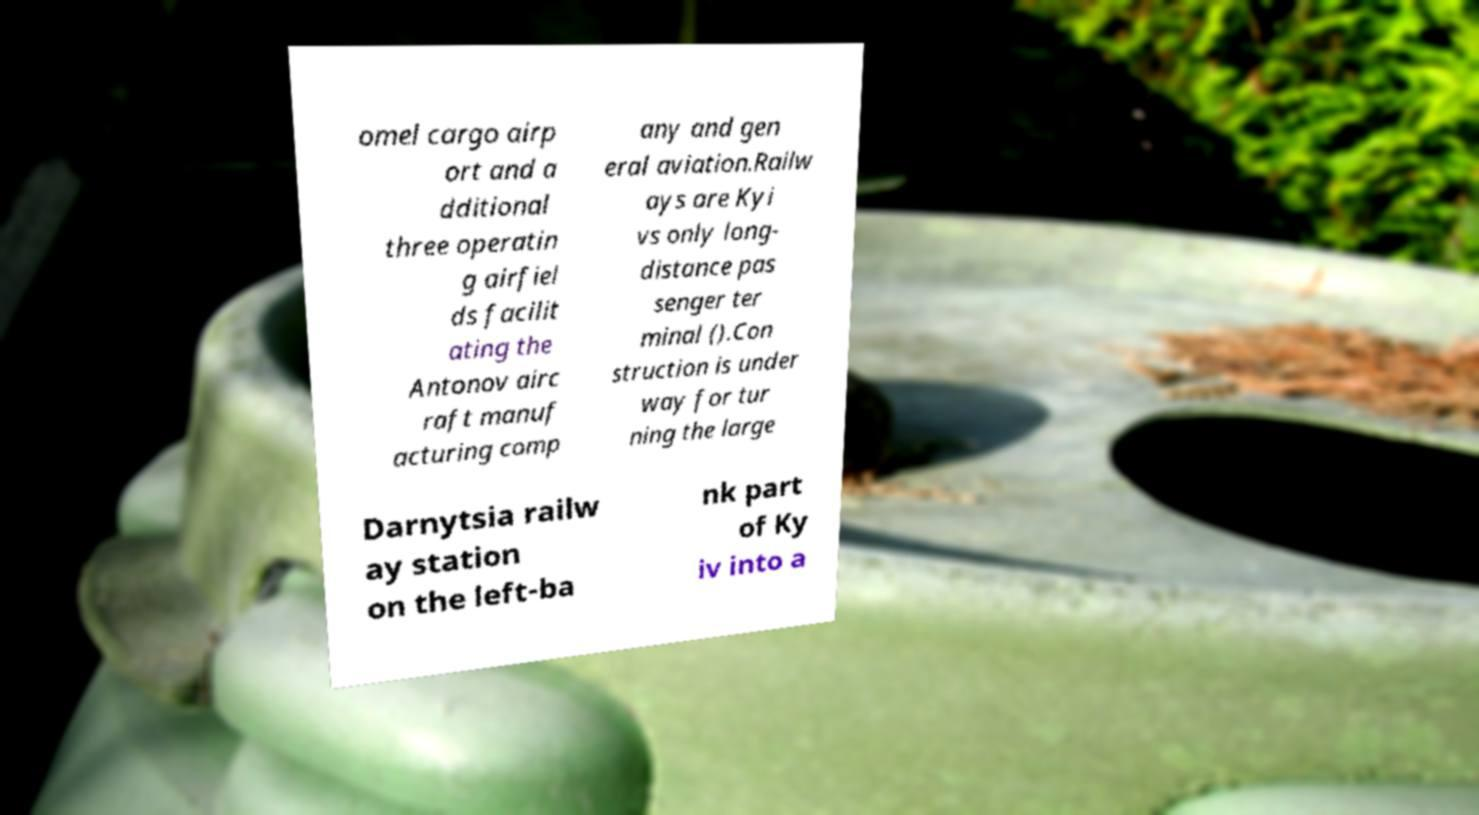Can you read and provide the text displayed in the image?This photo seems to have some interesting text. Can you extract and type it out for me? omel cargo airp ort and a dditional three operatin g airfiel ds facilit ating the Antonov airc raft manuf acturing comp any and gen eral aviation.Railw ays are Kyi vs only long- distance pas senger ter minal ().Con struction is under way for tur ning the large Darnytsia railw ay station on the left-ba nk part of Ky iv into a 